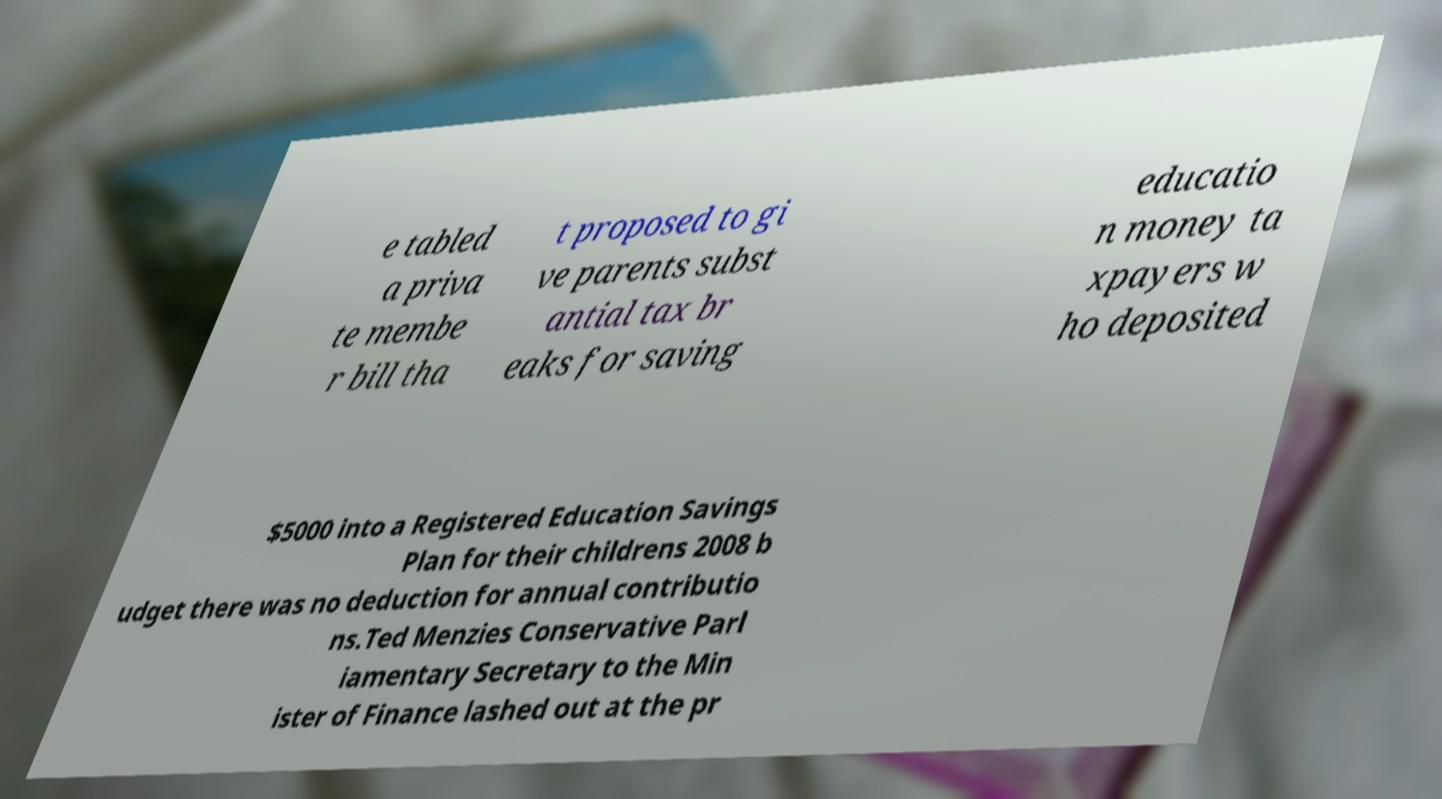Please read and relay the text visible in this image. What does it say? e tabled a priva te membe r bill tha t proposed to gi ve parents subst antial tax br eaks for saving educatio n money ta xpayers w ho deposited $5000 into a Registered Education Savings Plan for their childrens 2008 b udget there was no deduction for annual contributio ns.Ted Menzies Conservative Parl iamentary Secretary to the Min ister of Finance lashed out at the pr 